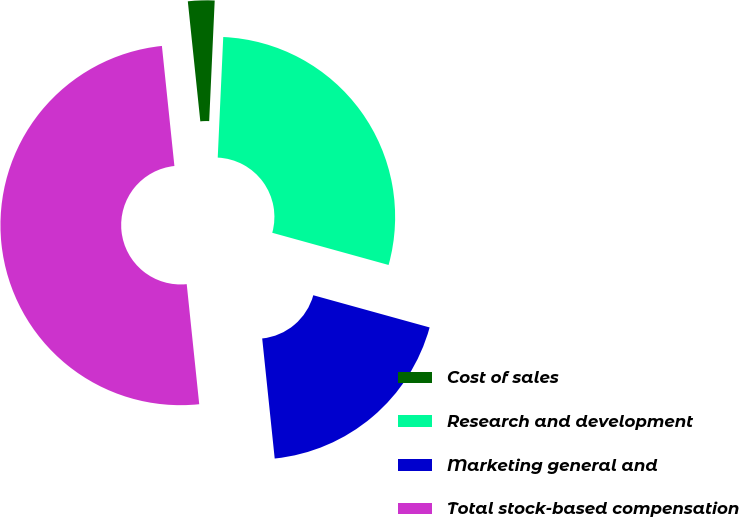Convert chart. <chart><loc_0><loc_0><loc_500><loc_500><pie_chart><fcel>Cost of sales<fcel>Research and development<fcel>Marketing general and<fcel>Total stock-based compensation<nl><fcel>2.38%<fcel>28.57%<fcel>19.05%<fcel>50.0%<nl></chart> 